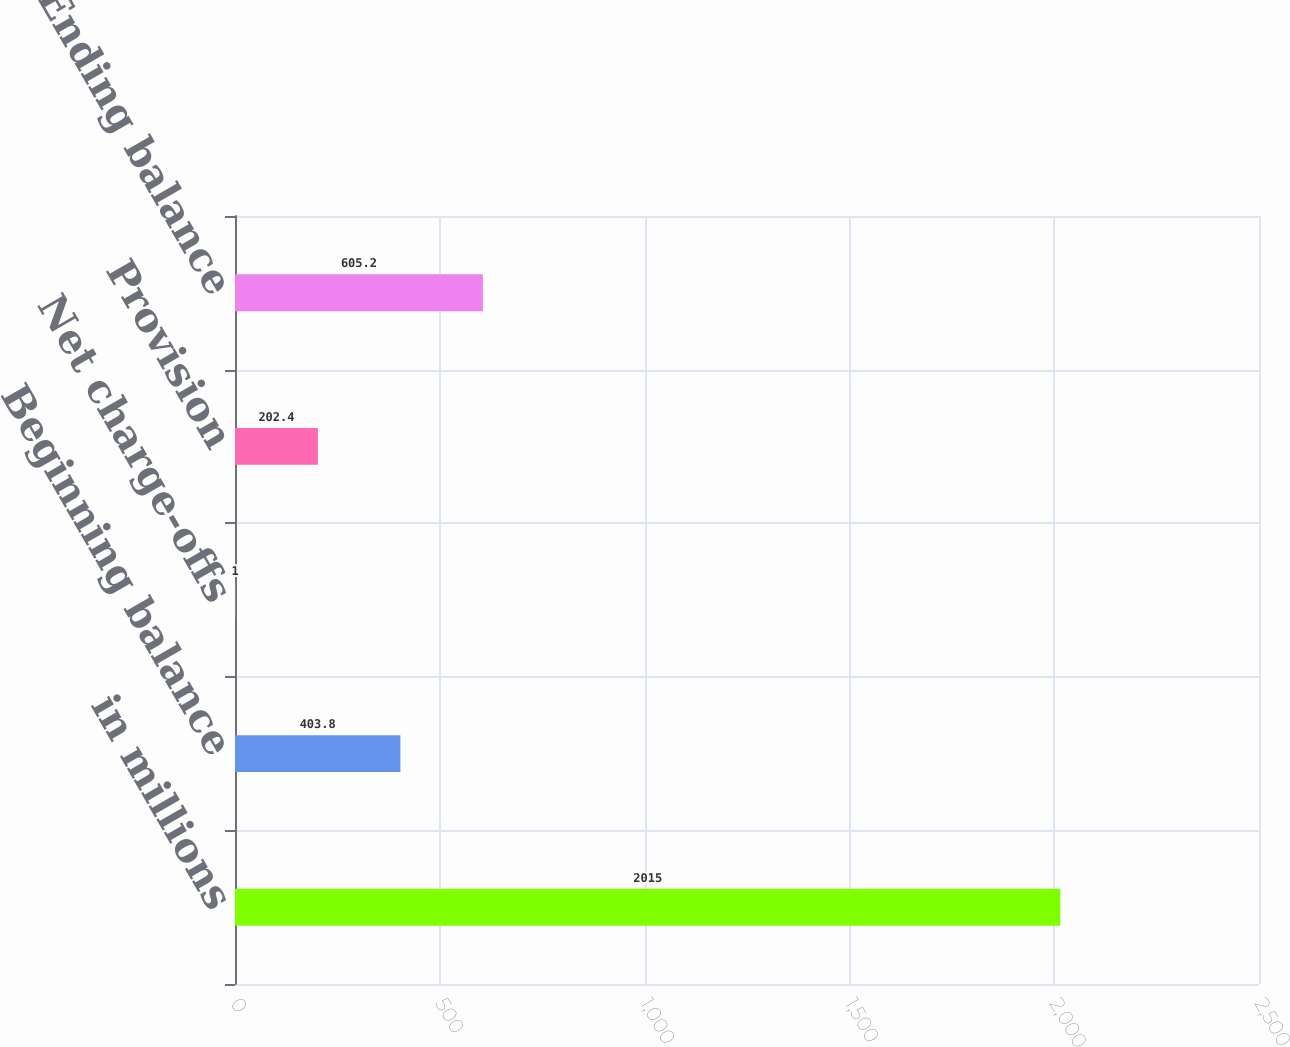Convert chart. <chart><loc_0><loc_0><loc_500><loc_500><bar_chart><fcel>in millions<fcel>Beginning balance<fcel>Net charge-offs<fcel>Provision<fcel>Ending balance<nl><fcel>2015<fcel>403.8<fcel>1<fcel>202.4<fcel>605.2<nl></chart> 